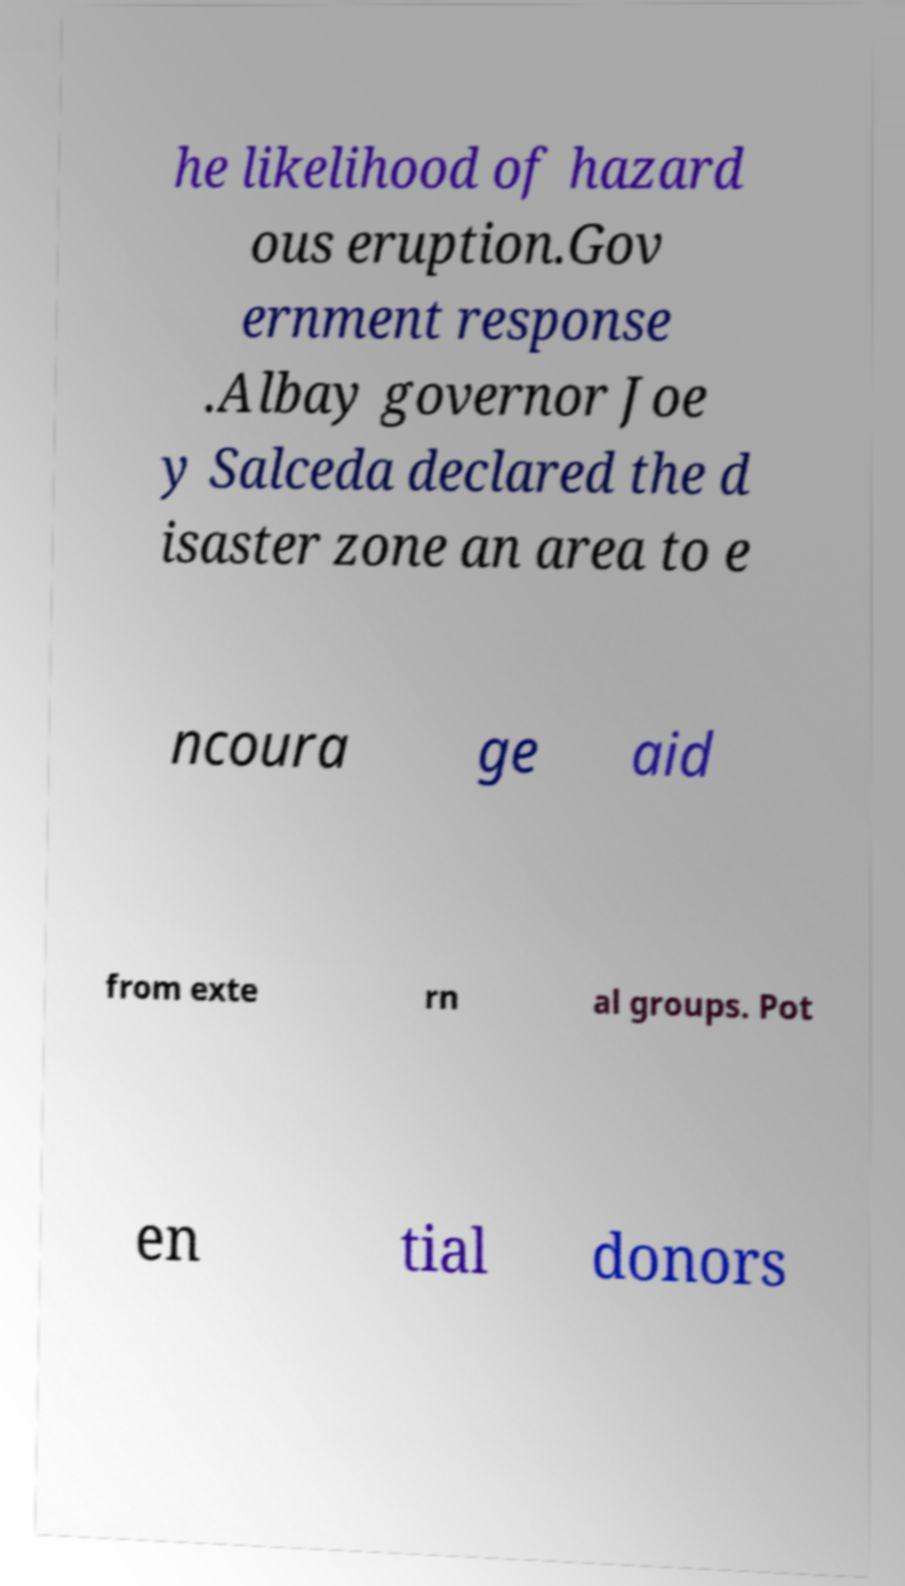Can you accurately transcribe the text from the provided image for me? he likelihood of hazard ous eruption.Gov ernment response .Albay governor Joe y Salceda declared the d isaster zone an area to e ncoura ge aid from exte rn al groups. Pot en tial donors 